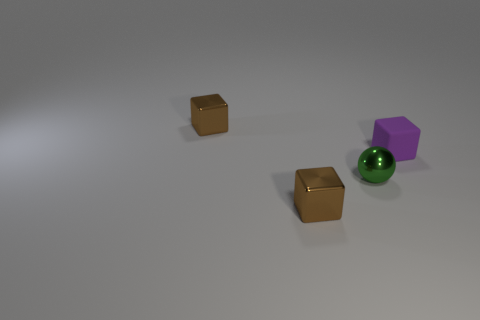Subtract all shiny blocks. How many blocks are left? 1 Subtract all balls. How many objects are left? 3 Add 1 large brown metallic things. How many objects exist? 5 Add 2 tiny blocks. How many tiny blocks are left? 5 Add 3 tiny cyan metal things. How many tiny cyan metal things exist? 3 Subtract 0 gray cylinders. How many objects are left? 4 Subtract all small metal balls. Subtract all small rubber objects. How many objects are left? 2 